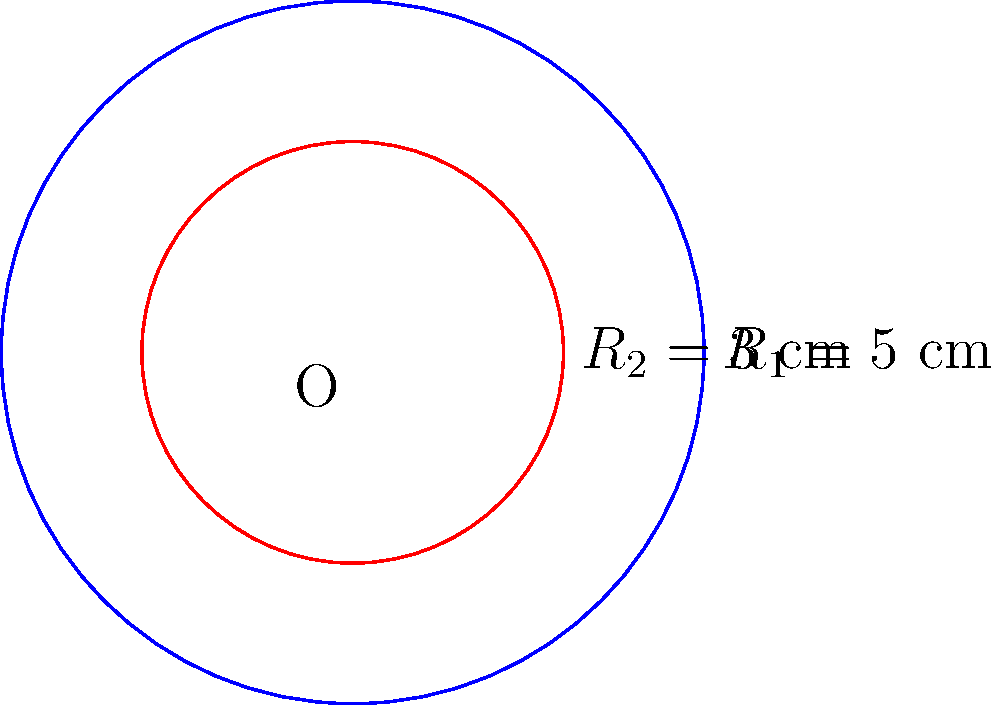In a detoxification reactor design, two concentric circular membranes are used to separate different phases of the process. The outer membrane has a radius ($R_1$) of 5 cm, while the inner membrane has a radius ($R_2$) of 3 cm. Calculate the area of the region between these two membranes, which represents the active detoxification zone. Express your answer in square centimeters (cm²). To find the area between two concentric circles, we need to:

1. Calculate the area of the larger circle (outer membrane):
   $$A_1 = \pi R_1^2 = \pi (5\text{ cm})^2 = 25\pi \text{ cm}^2$$

2. Calculate the area of the smaller circle (inner membrane):
   $$A_2 = \pi R_2^2 = \pi (3\text{ cm})^2 = 9\pi \text{ cm}^2$$

3. Subtract the area of the smaller circle from the larger circle:
   $$A_{\text{between}} = A_1 - A_2 = 25\pi \text{ cm}^2 - 9\pi \text{ cm}^2 = 16\pi \text{ cm}^2$$

4. Simplify:
   $$A_{\text{between}} = 16\pi \text{ cm}^2 \approx 50.27 \text{ cm}^2$$

The area of the active detoxification zone between the two membranes is $16\pi \text{ cm}^2$ or approximately 50.27 cm².
Answer: $16\pi \text{ cm}^2$ 